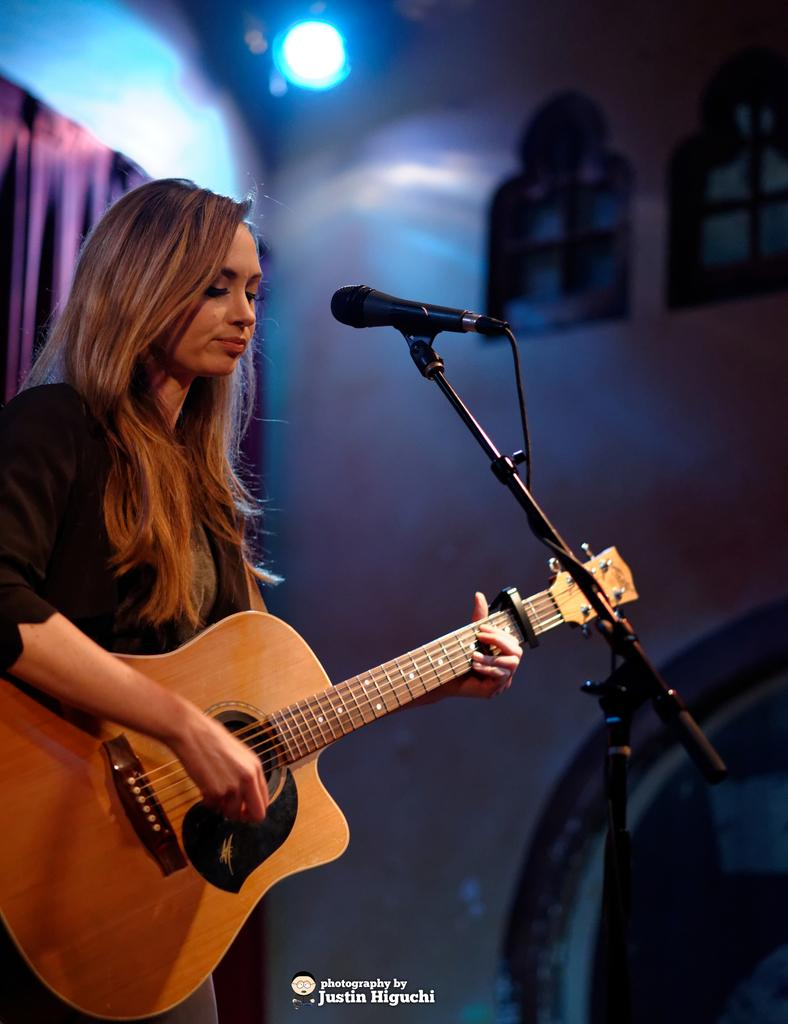Who is the main subject in the image? There is a woman in the image. What is the woman doing in the image? The woman is playing a guitar. What object is in front of the woman? There is a microphone in front of the woman. What can be seen in the background of the image? There is a curtain, a wall, and a light in the background of the image. What is the chance of the woman winning a race in the image? There is no race or indication of any athletic activity in the image, so it's not possible to determine the woman's chances of winning a race. 